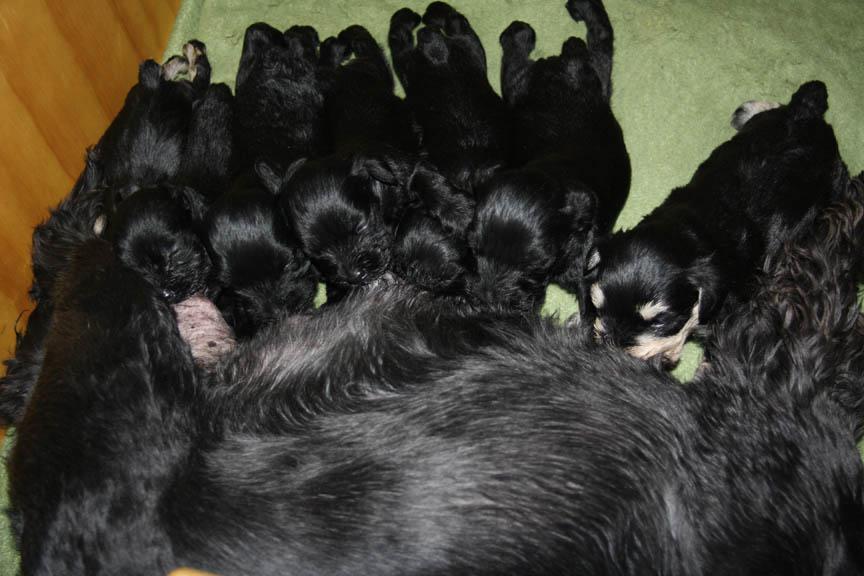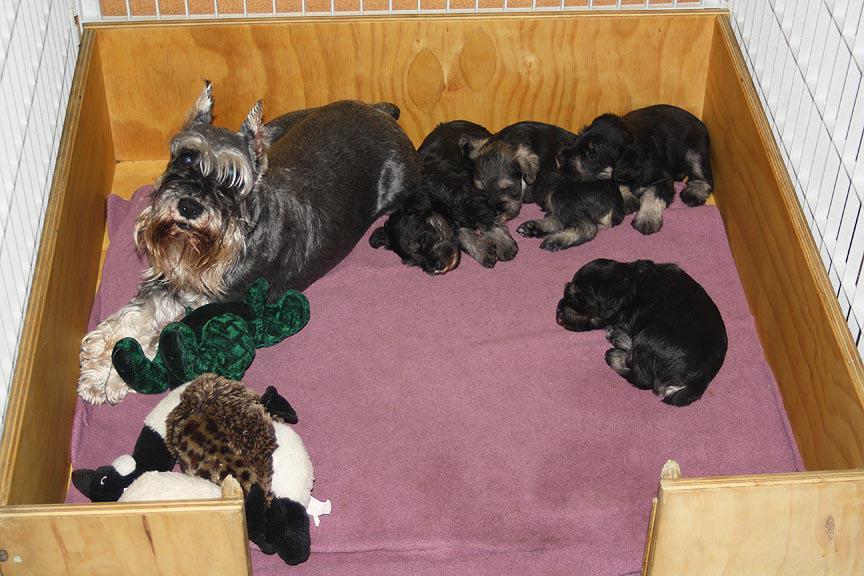The first image is the image on the left, the second image is the image on the right. Analyze the images presented: Is the assertion "There is a single puppy being held in the air in one image." valid? Answer yes or no. No. The first image is the image on the left, the second image is the image on the right. Evaluate the accuracy of this statement regarding the images: "A human is holding the puppy in the image on the right.". Is it true? Answer yes or no. No. 